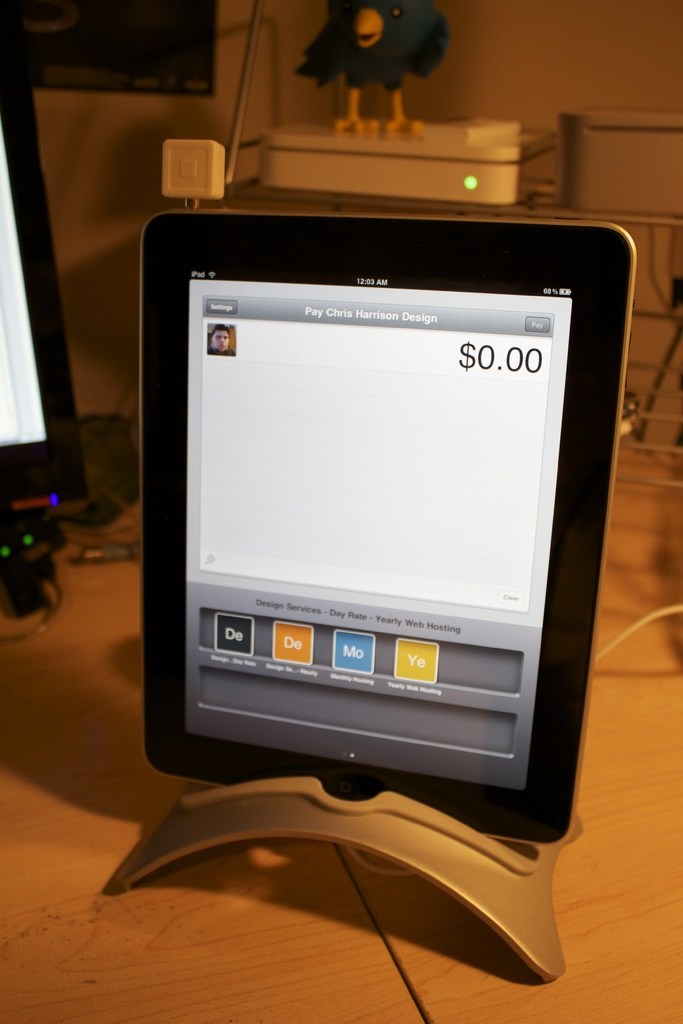What are the payment options shown on the device screen? The device screen displays several payment options for web hosting services: Day rate, Monthly rate, and Yearly rate. 